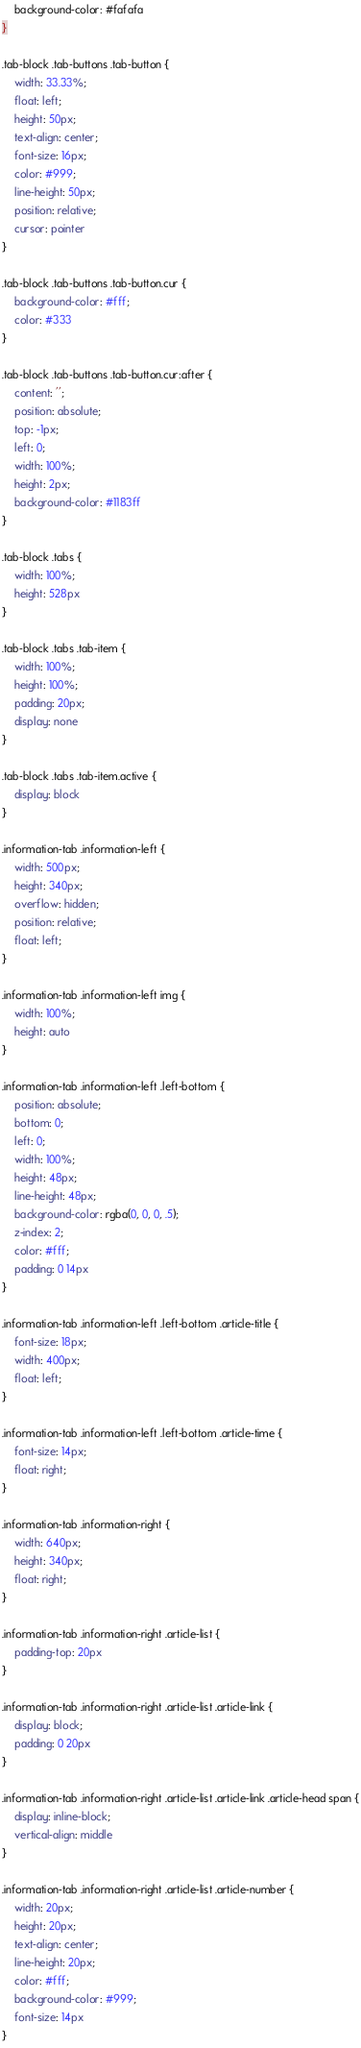<code> <loc_0><loc_0><loc_500><loc_500><_CSS_>	background-color: #fafafa
}

.tab-block .tab-buttons .tab-button {
	width: 33.33%;
	float: left;
	height: 50px;
	text-align: center;
	font-size: 16px;
	color: #999;
	line-height: 50px;
	position: relative;
	cursor: pointer
}

.tab-block .tab-buttons .tab-button.cur {
	background-color: #fff;
	color: #333
}

.tab-block .tab-buttons .tab-button.cur:after {
	content: '';
	position: absolute;
	top: -1px;
	left: 0;
	width: 100%;
	height: 2px;
	background-color: #1183ff
}

.tab-block .tabs {
	width: 100%;
	height: 528px
}

.tab-block .tabs .tab-item {
	width: 100%;
	height: 100%;
	padding: 20px;
	display: none
}

.tab-block .tabs .tab-item.active {
	display: block
}

.information-tab .information-left {
	width: 500px;
	height: 340px;
	overflow: hidden;
	position: relative;
	float: left;
}

.information-tab .information-left img {
	width: 100%;
	height: auto
}

.information-tab .information-left .left-bottom {
	position: absolute;
	bottom: 0;
	left: 0;
	width: 100%;
	height: 48px;
	line-height: 48px;
	background-color: rgba(0, 0, 0, .5);
	z-index: 2;
	color: #fff;
	padding: 0 14px
}

.information-tab .information-left .left-bottom .article-title {
	font-size: 18px;
	width: 400px;
	float: left;
}

.information-tab .information-left .left-bottom .article-time {
	font-size: 14px;
	float: right;
}

.information-tab .information-right {
	width: 640px;
	height: 340px;
	float: right;
}

.information-tab .information-right .article-list {
	padding-top: 20px
}

.information-tab .information-right .article-list .article-link {
	display: block;
	padding: 0 20px
}

.information-tab .information-right .article-list .article-link .article-head span {
	display: inline-block;
	vertical-align: middle
}

.information-tab .information-right .article-list .article-number {
	width: 20px;
	height: 20px;
	text-align: center;
	line-height: 20px;
	color: #fff;
	background-color: #999;
	font-size: 14px
}
</code> 